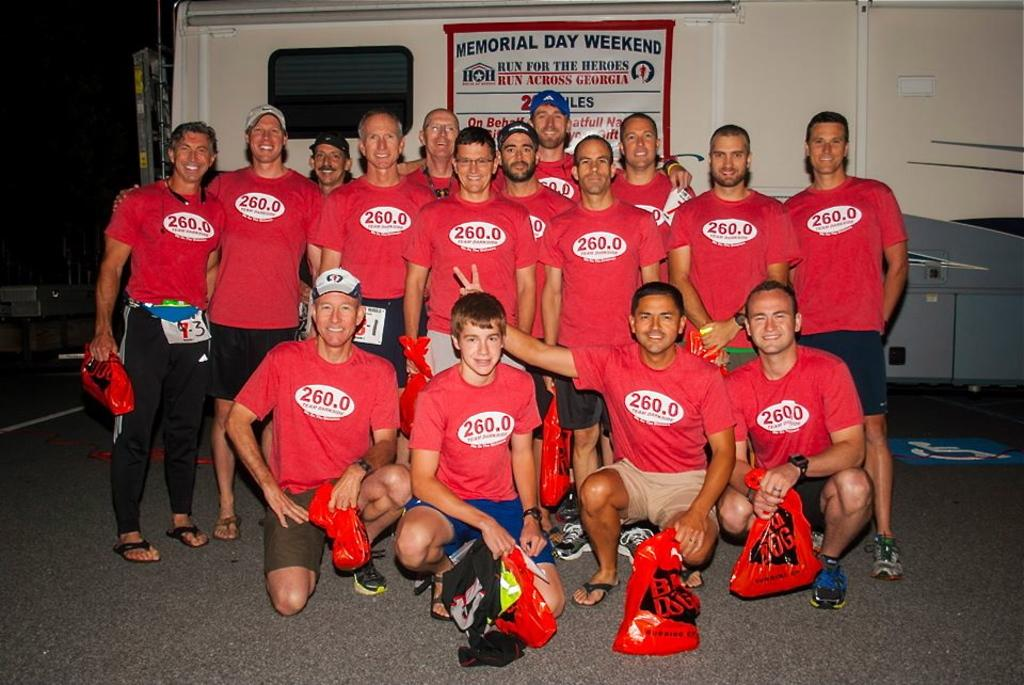<image>
Create a compact narrative representing the image presented. The men appear to have participated in the Memorial Day Weekend Run for the Heroes. 